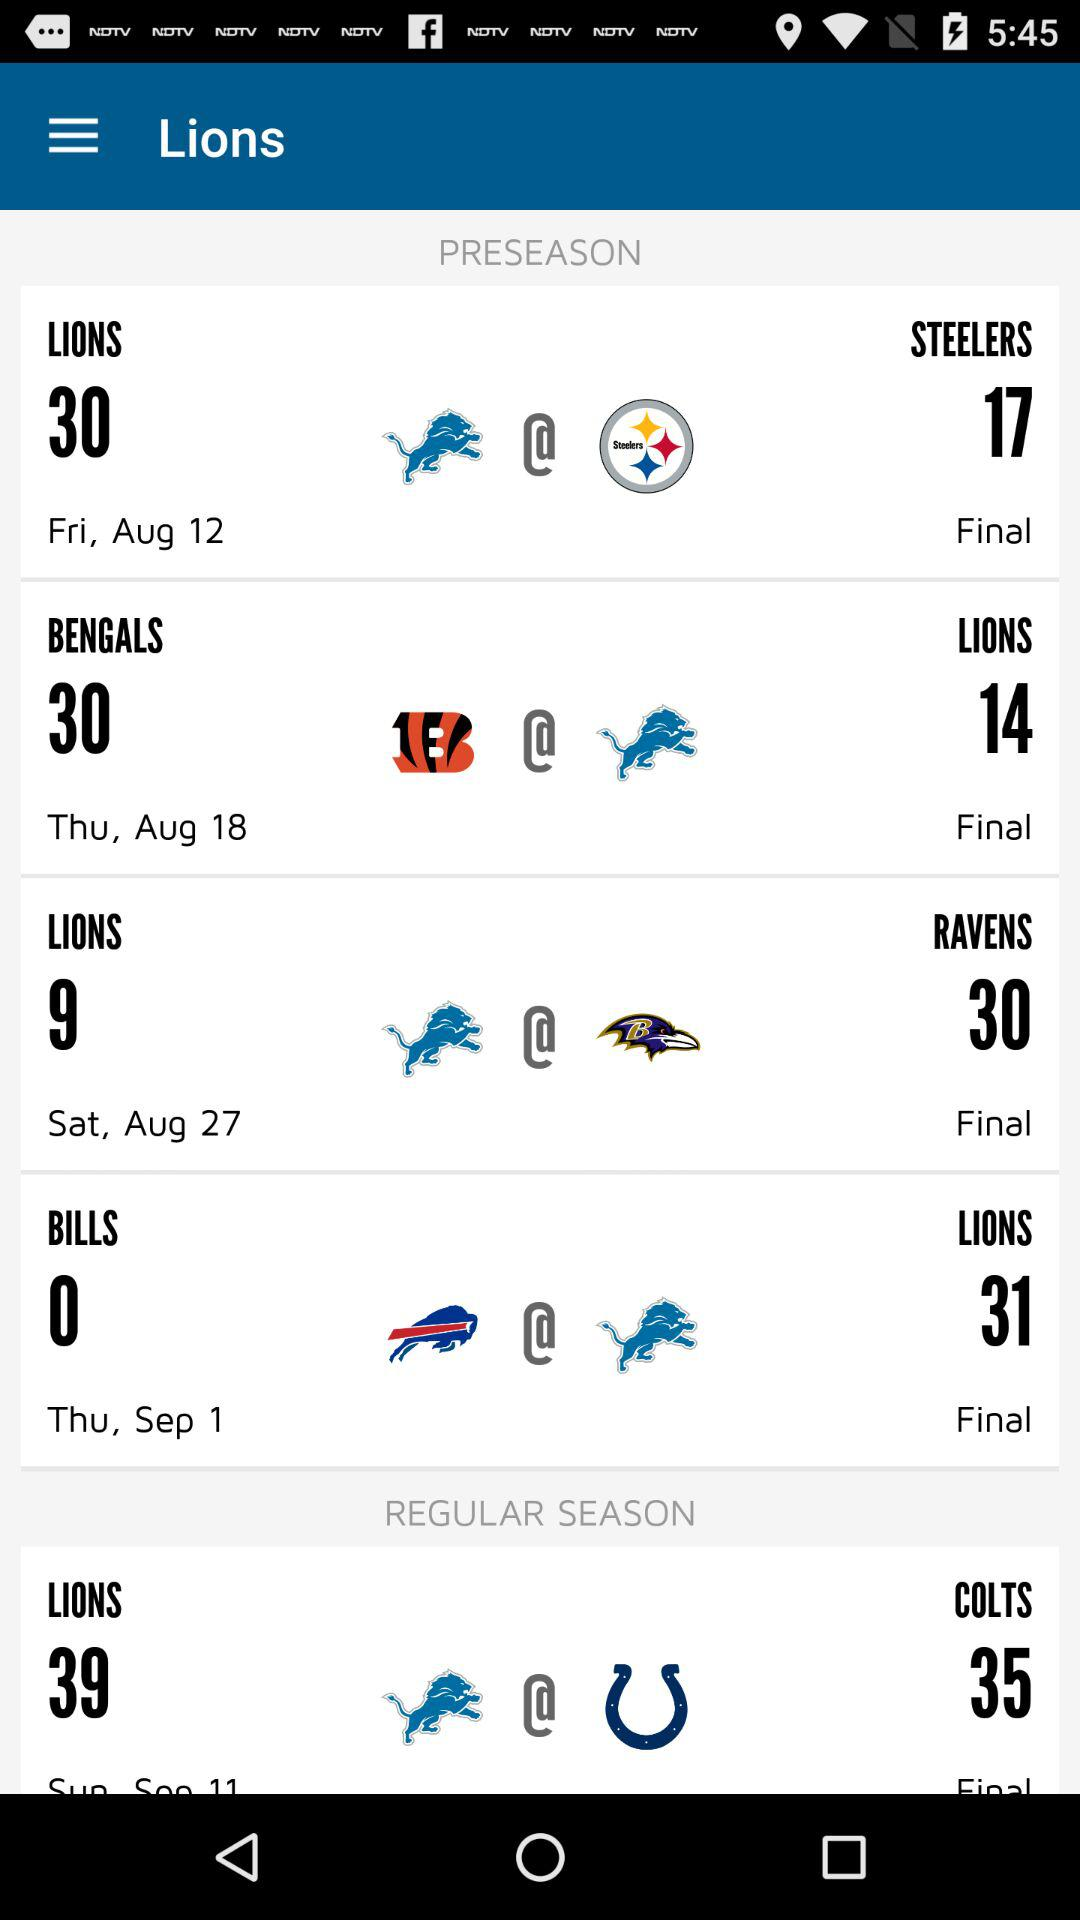Which are the 2 teams in the regular season? The 2 teams are "LIONS" and "COLTS". 